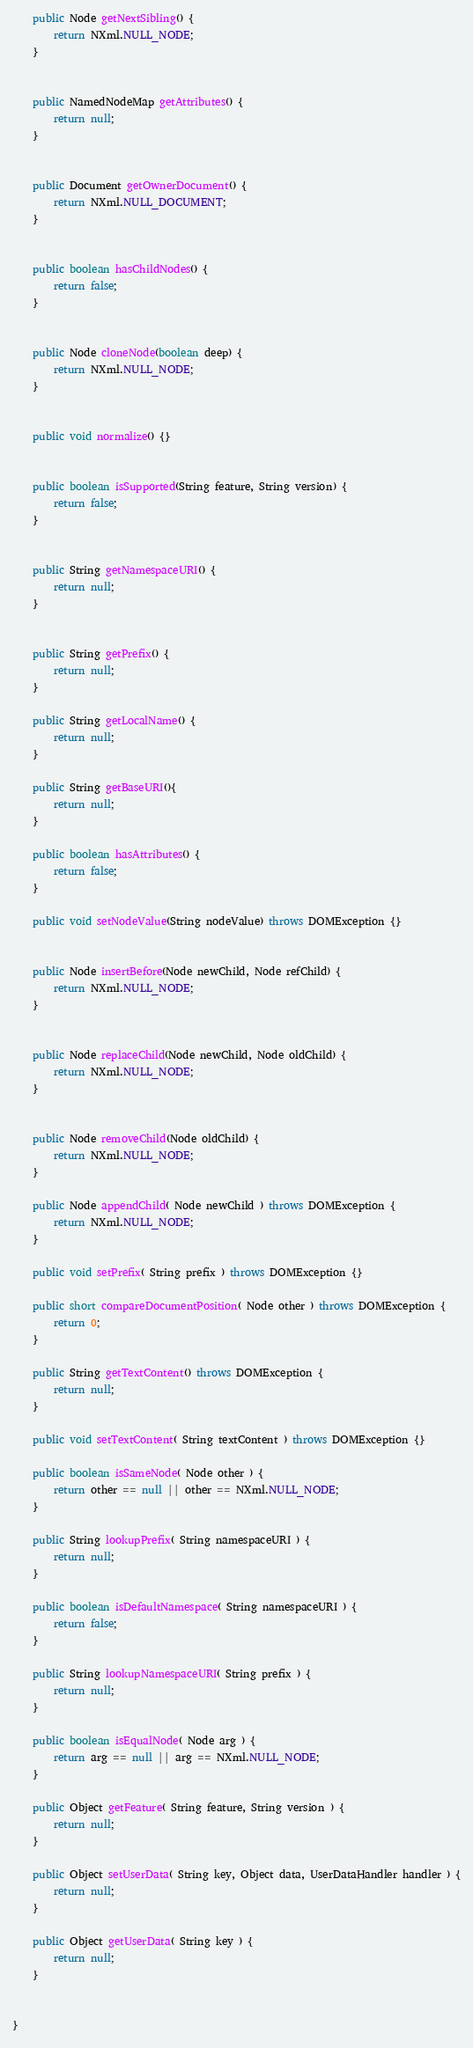Convert code to text. <code><loc_0><loc_0><loc_500><loc_500><_Java_>    public Node getNextSibling() {
        return NXml.NULL_NODE;
    }


    public NamedNodeMap getAttributes() {
        return null;
    }


    public Document getOwnerDocument() {
        return NXml.NULL_DOCUMENT;
    }


    public boolean hasChildNodes() {
        return false;
    }


    public Node cloneNode(boolean deep) {
        return NXml.NULL_NODE;
    }


    public void normalize() {}


    public boolean isSupported(String feature, String version) {
        return false;
    }


    public String getNamespaceURI() {
        return null;
    }


    public String getPrefix() {
        return null;
    }

    public String getLocalName() {
        return null;
    }

    public String getBaseURI(){
        return null;
    }

    public boolean hasAttributes() {
        return false;
    }

    public void setNodeValue(String nodeValue) throws DOMException {}


    public Node insertBefore(Node newChild, Node refChild) {
        return NXml.NULL_NODE;
    }


    public Node replaceChild(Node newChild, Node oldChild) {
    	return NXml.NULL_NODE;
    }


    public Node removeChild(Node oldChild) {
    	return NXml.NULL_NODE;
    }

    public Node appendChild( Node newChild ) throws DOMException {
		return NXml.NULL_NODE;
    }

    public void setPrefix( String prefix ) throws DOMException {}

    public short compareDocumentPosition( Node other ) throws DOMException {
	    return 0;
    }

    public String getTextContent() throws DOMException {
	    return null;
    }

    public void setTextContent( String textContent ) throws DOMException {}

    public boolean isSameNode( Node other ) {
    	return other == null || other == NXml.NULL_NODE;
    }

    public String lookupPrefix( String namespaceURI ) {
	    return null;
    }

    public boolean isDefaultNamespace( String namespaceURI ) {
	    return false;
    }

    public String lookupNamespaceURI( String prefix ) {
	    return null;
    }

    public boolean isEqualNode( Node arg ) {
    	return arg == null || arg == NXml.NULL_NODE;
    }

    public Object getFeature( String feature, String version ) {
	    return null;
    }

    public Object setUserData( String key, Object data, UserDataHandler handler ) {
	    return null;
    }

    public Object getUserData( String key ) {
	    return null;
    }


}
</code> 